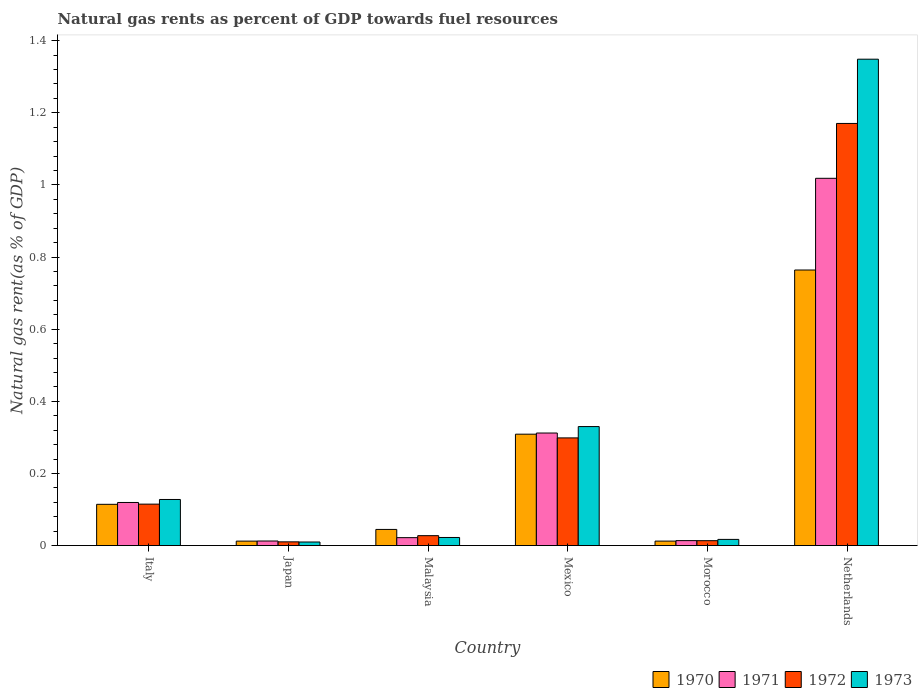Are the number of bars per tick equal to the number of legend labels?
Your answer should be very brief. Yes. What is the label of the 5th group of bars from the left?
Offer a terse response. Morocco. In how many cases, is the number of bars for a given country not equal to the number of legend labels?
Offer a terse response. 0. What is the natural gas rent in 1971 in Japan?
Your response must be concise. 0.01. Across all countries, what is the maximum natural gas rent in 1973?
Ensure brevity in your answer.  1.35. Across all countries, what is the minimum natural gas rent in 1972?
Offer a terse response. 0.01. What is the total natural gas rent in 1970 in the graph?
Ensure brevity in your answer.  1.26. What is the difference between the natural gas rent in 1970 in Japan and that in Mexico?
Offer a very short reply. -0.3. What is the difference between the natural gas rent in 1973 in Malaysia and the natural gas rent in 1970 in Netherlands?
Offer a very short reply. -0.74. What is the average natural gas rent in 1970 per country?
Ensure brevity in your answer.  0.21. What is the difference between the natural gas rent of/in 1970 and natural gas rent of/in 1971 in Netherlands?
Offer a terse response. -0.25. What is the ratio of the natural gas rent in 1972 in Malaysia to that in Netherlands?
Provide a succinct answer. 0.02. What is the difference between the highest and the second highest natural gas rent in 1972?
Your response must be concise. -0.87. What is the difference between the highest and the lowest natural gas rent in 1970?
Ensure brevity in your answer.  0.75. In how many countries, is the natural gas rent in 1973 greater than the average natural gas rent in 1973 taken over all countries?
Your answer should be very brief. 2. Is the sum of the natural gas rent in 1971 in Mexico and Morocco greater than the maximum natural gas rent in 1973 across all countries?
Make the answer very short. No. Is it the case that in every country, the sum of the natural gas rent in 1971 and natural gas rent in 1973 is greater than the sum of natural gas rent in 1972 and natural gas rent in 1970?
Make the answer very short. No. Are all the bars in the graph horizontal?
Give a very brief answer. No. How many countries are there in the graph?
Give a very brief answer. 6. Are the values on the major ticks of Y-axis written in scientific E-notation?
Your answer should be very brief. No. Does the graph contain grids?
Offer a very short reply. No. Where does the legend appear in the graph?
Provide a succinct answer. Bottom right. What is the title of the graph?
Offer a terse response. Natural gas rents as percent of GDP towards fuel resources. Does "1984" appear as one of the legend labels in the graph?
Offer a very short reply. No. What is the label or title of the X-axis?
Provide a short and direct response. Country. What is the label or title of the Y-axis?
Keep it short and to the point. Natural gas rent(as % of GDP). What is the Natural gas rent(as % of GDP) in 1970 in Italy?
Offer a very short reply. 0.11. What is the Natural gas rent(as % of GDP) in 1971 in Italy?
Keep it short and to the point. 0.12. What is the Natural gas rent(as % of GDP) of 1972 in Italy?
Ensure brevity in your answer.  0.11. What is the Natural gas rent(as % of GDP) in 1973 in Italy?
Offer a very short reply. 0.13. What is the Natural gas rent(as % of GDP) of 1970 in Japan?
Offer a terse response. 0.01. What is the Natural gas rent(as % of GDP) in 1971 in Japan?
Give a very brief answer. 0.01. What is the Natural gas rent(as % of GDP) in 1972 in Japan?
Make the answer very short. 0.01. What is the Natural gas rent(as % of GDP) in 1973 in Japan?
Ensure brevity in your answer.  0.01. What is the Natural gas rent(as % of GDP) in 1970 in Malaysia?
Your response must be concise. 0.04. What is the Natural gas rent(as % of GDP) of 1971 in Malaysia?
Provide a succinct answer. 0.02. What is the Natural gas rent(as % of GDP) of 1972 in Malaysia?
Make the answer very short. 0.03. What is the Natural gas rent(as % of GDP) of 1973 in Malaysia?
Provide a short and direct response. 0.02. What is the Natural gas rent(as % of GDP) of 1970 in Mexico?
Your answer should be very brief. 0.31. What is the Natural gas rent(as % of GDP) in 1971 in Mexico?
Provide a succinct answer. 0.31. What is the Natural gas rent(as % of GDP) in 1972 in Mexico?
Offer a terse response. 0.3. What is the Natural gas rent(as % of GDP) in 1973 in Mexico?
Your answer should be compact. 0.33. What is the Natural gas rent(as % of GDP) of 1970 in Morocco?
Ensure brevity in your answer.  0.01. What is the Natural gas rent(as % of GDP) in 1971 in Morocco?
Keep it short and to the point. 0.01. What is the Natural gas rent(as % of GDP) in 1972 in Morocco?
Give a very brief answer. 0.01. What is the Natural gas rent(as % of GDP) in 1973 in Morocco?
Your response must be concise. 0.02. What is the Natural gas rent(as % of GDP) in 1970 in Netherlands?
Keep it short and to the point. 0.76. What is the Natural gas rent(as % of GDP) in 1971 in Netherlands?
Your answer should be very brief. 1.02. What is the Natural gas rent(as % of GDP) of 1972 in Netherlands?
Your response must be concise. 1.17. What is the Natural gas rent(as % of GDP) of 1973 in Netherlands?
Ensure brevity in your answer.  1.35. Across all countries, what is the maximum Natural gas rent(as % of GDP) of 1970?
Your response must be concise. 0.76. Across all countries, what is the maximum Natural gas rent(as % of GDP) of 1971?
Your answer should be very brief. 1.02. Across all countries, what is the maximum Natural gas rent(as % of GDP) in 1972?
Provide a short and direct response. 1.17. Across all countries, what is the maximum Natural gas rent(as % of GDP) in 1973?
Provide a short and direct response. 1.35. Across all countries, what is the minimum Natural gas rent(as % of GDP) in 1970?
Give a very brief answer. 0.01. Across all countries, what is the minimum Natural gas rent(as % of GDP) in 1971?
Give a very brief answer. 0.01. Across all countries, what is the minimum Natural gas rent(as % of GDP) in 1972?
Your response must be concise. 0.01. Across all countries, what is the minimum Natural gas rent(as % of GDP) in 1973?
Offer a terse response. 0.01. What is the total Natural gas rent(as % of GDP) of 1970 in the graph?
Offer a very short reply. 1.26. What is the total Natural gas rent(as % of GDP) of 1971 in the graph?
Give a very brief answer. 1.5. What is the total Natural gas rent(as % of GDP) in 1972 in the graph?
Offer a very short reply. 1.64. What is the total Natural gas rent(as % of GDP) of 1973 in the graph?
Provide a short and direct response. 1.86. What is the difference between the Natural gas rent(as % of GDP) in 1970 in Italy and that in Japan?
Give a very brief answer. 0.1. What is the difference between the Natural gas rent(as % of GDP) in 1971 in Italy and that in Japan?
Keep it short and to the point. 0.11. What is the difference between the Natural gas rent(as % of GDP) of 1972 in Italy and that in Japan?
Provide a short and direct response. 0.1. What is the difference between the Natural gas rent(as % of GDP) of 1973 in Italy and that in Japan?
Offer a very short reply. 0.12. What is the difference between the Natural gas rent(as % of GDP) of 1970 in Italy and that in Malaysia?
Offer a terse response. 0.07. What is the difference between the Natural gas rent(as % of GDP) of 1971 in Italy and that in Malaysia?
Your answer should be very brief. 0.1. What is the difference between the Natural gas rent(as % of GDP) in 1972 in Italy and that in Malaysia?
Make the answer very short. 0.09. What is the difference between the Natural gas rent(as % of GDP) of 1973 in Italy and that in Malaysia?
Offer a terse response. 0.11. What is the difference between the Natural gas rent(as % of GDP) in 1970 in Italy and that in Mexico?
Make the answer very short. -0.19. What is the difference between the Natural gas rent(as % of GDP) of 1971 in Italy and that in Mexico?
Keep it short and to the point. -0.19. What is the difference between the Natural gas rent(as % of GDP) of 1972 in Italy and that in Mexico?
Make the answer very short. -0.18. What is the difference between the Natural gas rent(as % of GDP) of 1973 in Italy and that in Mexico?
Make the answer very short. -0.2. What is the difference between the Natural gas rent(as % of GDP) in 1970 in Italy and that in Morocco?
Provide a succinct answer. 0.1. What is the difference between the Natural gas rent(as % of GDP) in 1971 in Italy and that in Morocco?
Your answer should be very brief. 0.11. What is the difference between the Natural gas rent(as % of GDP) of 1972 in Italy and that in Morocco?
Give a very brief answer. 0.1. What is the difference between the Natural gas rent(as % of GDP) of 1973 in Italy and that in Morocco?
Your answer should be very brief. 0.11. What is the difference between the Natural gas rent(as % of GDP) in 1970 in Italy and that in Netherlands?
Offer a very short reply. -0.65. What is the difference between the Natural gas rent(as % of GDP) of 1971 in Italy and that in Netherlands?
Ensure brevity in your answer.  -0.9. What is the difference between the Natural gas rent(as % of GDP) in 1972 in Italy and that in Netherlands?
Your answer should be very brief. -1.06. What is the difference between the Natural gas rent(as % of GDP) in 1973 in Italy and that in Netherlands?
Provide a short and direct response. -1.22. What is the difference between the Natural gas rent(as % of GDP) in 1970 in Japan and that in Malaysia?
Your answer should be very brief. -0.03. What is the difference between the Natural gas rent(as % of GDP) of 1971 in Japan and that in Malaysia?
Provide a succinct answer. -0.01. What is the difference between the Natural gas rent(as % of GDP) in 1972 in Japan and that in Malaysia?
Provide a short and direct response. -0.02. What is the difference between the Natural gas rent(as % of GDP) in 1973 in Japan and that in Malaysia?
Give a very brief answer. -0.01. What is the difference between the Natural gas rent(as % of GDP) of 1970 in Japan and that in Mexico?
Make the answer very short. -0.3. What is the difference between the Natural gas rent(as % of GDP) in 1971 in Japan and that in Mexico?
Your response must be concise. -0.3. What is the difference between the Natural gas rent(as % of GDP) of 1972 in Japan and that in Mexico?
Provide a succinct answer. -0.29. What is the difference between the Natural gas rent(as % of GDP) of 1973 in Japan and that in Mexico?
Keep it short and to the point. -0.32. What is the difference between the Natural gas rent(as % of GDP) in 1970 in Japan and that in Morocco?
Keep it short and to the point. -0. What is the difference between the Natural gas rent(as % of GDP) of 1971 in Japan and that in Morocco?
Your answer should be very brief. -0. What is the difference between the Natural gas rent(as % of GDP) in 1972 in Japan and that in Morocco?
Provide a succinct answer. -0. What is the difference between the Natural gas rent(as % of GDP) in 1973 in Japan and that in Morocco?
Offer a very short reply. -0.01. What is the difference between the Natural gas rent(as % of GDP) of 1970 in Japan and that in Netherlands?
Your response must be concise. -0.75. What is the difference between the Natural gas rent(as % of GDP) of 1971 in Japan and that in Netherlands?
Make the answer very short. -1.01. What is the difference between the Natural gas rent(as % of GDP) in 1972 in Japan and that in Netherlands?
Offer a very short reply. -1.16. What is the difference between the Natural gas rent(as % of GDP) of 1973 in Japan and that in Netherlands?
Ensure brevity in your answer.  -1.34. What is the difference between the Natural gas rent(as % of GDP) of 1970 in Malaysia and that in Mexico?
Make the answer very short. -0.26. What is the difference between the Natural gas rent(as % of GDP) of 1971 in Malaysia and that in Mexico?
Make the answer very short. -0.29. What is the difference between the Natural gas rent(as % of GDP) in 1972 in Malaysia and that in Mexico?
Offer a terse response. -0.27. What is the difference between the Natural gas rent(as % of GDP) in 1973 in Malaysia and that in Mexico?
Offer a very short reply. -0.31. What is the difference between the Natural gas rent(as % of GDP) in 1970 in Malaysia and that in Morocco?
Your answer should be compact. 0.03. What is the difference between the Natural gas rent(as % of GDP) of 1971 in Malaysia and that in Morocco?
Give a very brief answer. 0.01. What is the difference between the Natural gas rent(as % of GDP) of 1972 in Malaysia and that in Morocco?
Make the answer very short. 0.01. What is the difference between the Natural gas rent(as % of GDP) of 1973 in Malaysia and that in Morocco?
Provide a short and direct response. 0.01. What is the difference between the Natural gas rent(as % of GDP) in 1970 in Malaysia and that in Netherlands?
Provide a short and direct response. -0.72. What is the difference between the Natural gas rent(as % of GDP) of 1971 in Malaysia and that in Netherlands?
Make the answer very short. -1. What is the difference between the Natural gas rent(as % of GDP) in 1972 in Malaysia and that in Netherlands?
Your answer should be very brief. -1.14. What is the difference between the Natural gas rent(as % of GDP) of 1973 in Malaysia and that in Netherlands?
Provide a succinct answer. -1.33. What is the difference between the Natural gas rent(as % of GDP) of 1970 in Mexico and that in Morocco?
Provide a succinct answer. 0.3. What is the difference between the Natural gas rent(as % of GDP) of 1971 in Mexico and that in Morocco?
Keep it short and to the point. 0.3. What is the difference between the Natural gas rent(as % of GDP) of 1972 in Mexico and that in Morocco?
Provide a succinct answer. 0.28. What is the difference between the Natural gas rent(as % of GDP) of 1973 in Mexico and that in Morocco?
Provide a succinct answer. 0.31. What is the difference between the Natural gas rent(as % of GDP) of 1970 in Mexico and that in Netherlands?
Offer a very short reply. -0.46. What is the difference between the Natural gas rent(as % of GDP) in 1971 in Mexico and that in Netherlands?
Make the answer very short. -0.71. What is the difference between the Natural gas rent(as % of GDP) of 1972 in Mexico and that in Netherlands?
Provide a succinct answer. -0.87. What is the difference between the Natural gas rent(as % of GDP) in 1973 in Mexico and that in Netherlands?
Offer a very short reply. -1.02. What is the difference between the Natural gas rent(as % of GDP) in 1970 in Morocco and that in Netherlands?
Give a very brief answer. -0.75. What is the difference between the Natural gas rent(as % of GDP) in 1971 in Morocco and that in Netherlands?
Give a very brief answer. -1. What is the difference between the Natural gas rent(as % of GDP) of 1972 in Morocco and that in Netherlands?
Your answer should be very brief. -1.16. What is the difference between the Natural gas rent(as % of GDP) of 1973 in Morocco and that in Netherlands?
Keep it short and to the point. -1.33. What is the difference between the Natural gas rent(as % of GDP) of 1970 in Italy and the Natural gas rent(as % of GDP) of 1971 in Japan?
Ensure brevity in your answer.  0.1. What is the difference between the Natural gas rent(as % of GDP) in 1970 in Italy and the Natural gas rent(as % of GDP) in 1972 in Japan?
Ensure brevity in your answer.  0.1. What is the difference between the Natural gas rent(as % of GDP) of 1970 in Italy and the Natural gas rent(as % of GDP) of 1973 in Japan?
Keep it short and to the point. 0.1. What is the difference between the Natural gas rent(as % of GDP) in 1971 in Italy and the Natural gas rent(as % of GDP) in 1972 in Japan?
Your answer should be very brief. 0.11. What is the difference between the Natural gas rent(as % of GDP) in 1971 in Italy and the Natural gas rent(as % of GDP) in 1973 in Japan?
Ensure brevity in your answer.  0.11. What is the difference between the Natural gas rent(as % of GDP) in 1972 in Italy and the Natural gas rent(as % of GDP) in 1973 in Japan?
Give a very brief answer. 0.1. What is the difference between the Natural gas rent(as % of GDP) of 1970 in Italy and the Natural gas rent(as % of GDP) of 1971 in Malaysia?
Your response must be concise. 0.09. What is the difference between the Natural gas rent(as % of GDP) in 1970 in Italy and the Natural gas rent(as % of GDP) in 1972 in Malaysia?
Your answer should be compact. 0.09. What is the difference between the Natural gas rent(as % of GDP) of 1970 in Italy and the Natural gas rent(as % of GDP) of 1973 in Malaysia?
Offer a very short reply. 0.09. What is the difference between the Natural gas rent(as % of GDP) in 1971 in Italy and the Natural gas rent(as % of GDP) in 1972 in Malaysia?
Your answer should be very brief. 0.09. What is the difference between the Natural gas rent(as % of GDP) of 1971 in Italy and the Natural gas rent(as % of GDP) of 1973 in Malaysia?
Provide a short and direct response. 0.1. What is the difference between the Natural gas rent(as % of GDP) in 1972 in Italy and the Natural gas rent(as % of GDP) in 1973 in Malaysia?
Ensure brevity in your answer.  0.09. What is the difference between the Natural gas rent(as % of GDP) in 1970 in Italy and the Natural gas rent(as % of GDP) in 1971 in Mexico?
Keep it short and to the point. -0.2. What is the difference between the Natural gas rent(as % of GDP) in 1970 in Italy and the Natural gas rent(as % of GDP) in 1972 in Mexico?
Keep it short and to the point. -0.18. What is the difference between the Natural gas rent(as % of GDP) of 1970 in Italy and the Natural gas rent(as % of GDP) of 1973 in Mexico?
Give a very brief answer. -0.22. What is the difference between the Natural gas rent(as % of GDP) of 1971 in Italy and the Natural gas rent(as % of GDP) of 1972 in Mexico?
Ensure brevity in your answer.  -0.18. What is the difference between the Natural gas rent(as % of GDP) in 1971 in Italy and the Natural gas rent(as % of GDP) in 1973 in Mexico?
Make the answer very short. -0.21. What is the difference between the Natural gas rent(as % of GDP) of 1972 in Italy and the Natural gas rent(as % of GDP) of 1973 in Mexico?
Offer a very short reply. -0.22. What is the difference between the Natural gas rent(as % of GDP) of 1970 in Italy and the Natural gas rent(as % of GDP) of 1971 in Morocco?
Your answer should be very brief. 0.1. What is the difference between the Natural gas rent(as % of GDP) of 1970 in Italy and the Natural gas rent(as % of GDP) of 1972 in Morocco?
Offer a very short reply. 0.1. What is the difference between the Natural gas rent(as % of GDP) of 1970 in Italy and the Natural gas rent(as % of GDP) of 1973 in Morocco?
Offer a very short reply. 0.1. What is the difference between the Natural gas rent(as % of GDP) of 1971 in Italy and the Natural gas rent(as % of GDP) of 1972 in Morocco?
Provide a short and direct response. 0.11. What is the difference between the Natural gas rent(as % of GDP) of 1971 in Italy and the Natural gas rent(as % of GDP) of 1973 in Morocco?
Offer a terse response. 0.1. What is the difference between the Natural gas rent(as % of GDP) of 1972 in Italy and the Natural gas rent(as % of GDP) of 1973 in Morocco?
Offer a very short reply. 0.1. What is the difference between the Natural gas rent(as % of GDP) in 1970 in Italy and the Natural gas rent(as % of GDP) in 1971 in Netherlands?
Give a very brief answer. -0.9. What is the difference between the Natural gas rent(as % of GDP) in 1970 in Italy and the Natural gas rent(as % of GDP) in 1972 in Netherlands?
Your answer should be very brief. -1.06. What is the difference between the Natural gas rent(as % of GDP) in 1970 in Italy and the Natural gas rent(as % of GDP) in 1973 in Netherlands?
Provide a succinct answer. -1.23. What is the difference between the Natural gas rent(as % of GDP) of 1971 in Italy and the Natural gas rent(as % of GDP) of 1972 in Netherlands?
Keep it short and to the point. -1.05. What is the difference between the Natural gas rent(as % of GDP) in 1971 in Italy and the Natural gas rent(as % of GDP) in 1973 in Netherlands?
Offer a very short reply. -1.23. What is the difference between the Natural gas rent(as % of GDP) in 1972 in Italy and the Natural gas rent(as % of GDP) in 1973 in Netherlands?
Keep it short and to the point. -1.23. What is the difference between the Natural gas rent(as % of GDP) of 1970 in Japan and the Natural gas rent(as % of GDP) of 1971 in Malaysia?
Your response must be concise. -0.01. What is the difference between the Natural gas rent(as % of GDP) of 1970 in Japan and the Natural gas rent(as % of GDP) of 1972 in Malaysia?
Your answer should be compact. -0.02. What is the difference between the Natural gas rent(as % of GDP) of 1970 in Japan and the Natural gas rent(as % of GDP) of 1973 in Malaysia?
Your response must be concise. -0.01. What is the difference between the Natural gas rent(as % of GDP) in 1971 in Japan and the Natural gas rent(as % of GDP) in 1972 in Malaysia?
Your answer should be very brief. -0.01. What is the difference between the Natural gas rent(as % of GDP) of 1971 in Japan and the Natural gas rent(as % of GDP) of 1973 in Malaysia?
Make the answer very short. -0.01. What is the difference between the Natural gas rent(as % of GDP) of 1972 in Japan and the Natural gas rent(as % of GDP) of 1973 in Malaysia?
Your answer should be very brief. -0.01. What is the difference between the Natural gas rent(as % of GDP) of 1970 in Japan and the Natural gas rent(as % of GDP) of 1971 in Mexico?
Give a very brief answer. -0.3. What is the difference between the Natural gas rent(as % of GDP) in 1970 in Japan and the Natural gas rent(as % of GDP) in 1972 in Mexico?
Keep it short and to the point. -0.29. What is the difference between the Natural gas rent(as % of GDP) in 1970 in Japan and the Natural gas rent(as % of GDP) in 1973 in Mexico?
Keep it short and to the point. -0.32. What is the difference between the Natural gas rent(as % of GDP) of 1971 in Japan and the Natural gas rent(as % of GDP) of 1972 in Mexico?
Keep it short and to the point. -0.29. What is the difference between the Natural gas rent(as % of GDP) in 1971 in Japan and the Natural gas rent(as % of GDP) in 1973 in Mexico?
Your answer should be compact. -0.32. What is the difference between the Natural gas rent(as % of GDP) in 1972 in Japan and the Natural gas rent(as % of GDP) in 1973 in Mexico?
Offer a terse response. -0.32. What is the difference between the Natural gas rent(as % of GDP) in 1970 in Japan and the Natural gas rent(as % of GDP) in 1971 in Morocco?
Provide a short and direct response. -0. What is the difference between the Natural gas rent(as % of GDP) in 1970 in Japan and the Natural gas rent(as % of GDP) in 1972 in Morocco?
Offer a terse response. -0. What is the difference between the Natural gas rent(as % of GDP) in 1970 in Japan and the Natural gas rent(as % of GDP) in 1973 in Morocco?
Offer a terse response. -0. What is the difference between the Natural gas rent(as % of GDP) in 1971 in Japan and the Natural gas rent(as % of GDP) in 1972 in Morocco?
Your response must be concise. -0. What is the difference between the Natural gas rent(as % of GDP) in 1971 in Japan and the Natural gas rent(as % of GDP) in 1973 in Morocco?
Offer a very short reply. -0. What is the difference between the Natural gas rent(as % of GDP) in 1972 in Japan and the Natural gas rent(as % of GDP) in 1973 in Morocco?
Your response must be concise. -0.01. What is the difference between the Natural gas rent(as % of GDP) of 1970 in Japan and the Natural gas rent(as % of GDP) of 1971 in Netherlands?
Offer a terse response. -1.01. What is the difference between the Natural gas rent(as % of GDP) in 1970 in Japan and the Natural gas rent(as % of GDP) in 1972 in Netherlands?
Your answer should be compact. -1.16. What is the difference between the Natural gas rent(as % of GDP) in 1970 in Japan and the Natural gas rent(as % of GDP) in 1973 in Netherlands?
Keep it short and to the point. -1.34. What is the difference between the Natural gas rent(as % of GDP) of 1971 in Japan and the Natural gas rent(as % of GDP) of 1972 in Netherlands?
Give a very brief answer. -1.16. What is the difference between the Natural gas rent(as % of GDP) of 1971 in Japan and the Natural gas rent(as % of GDP) of 1973 in Netherlands?
Ensure brevity in your answer.  -1.34. What is the difference between the Natural gas rent(as % of GDP) in 1972 in Japan and the Natural gas rent(as % of GDP) in 1973 in Netherlands?
Offer a terse response. -1.34. What is the difference between the Natural gas rent(as % of GDP) in 1970 in Malaysia and the Natural gas rent(as % of GDP) in 1971 in Mexico?
Make the answer very short. -0.27. What is the difference between the Natural gas rent(as % of GDP) in 1970 in Malaysia and the Natural gas rent(as % of GDP) in 1972 in Mexico?
Give a very brief answer. -0.25. What is the difference between the Natural gas rent(as % of GDP) of 1970 in Malaysia and the Natural gas rent(as % of GDP) of 1973 in Mexico?
Offer a very short reply. -0.29. What is the difference between the Natural gas rent(as % of GDP) of 1971 in Malaysia and the Natural gas rent(as % of GDP) of 1972 in Mexico?
Offer a terse response. -0.28. What is the difference between the Natural gas rent(as % of GDP) in 1971 in Malaysia and the Natural gas rent(as % of GDP) in 1973 in Mexico?
Your answer should be compact. -0.31. What is the difference between the Natural gas rent(as % of GDP) in 1972 in Malaysia and the Natural gas rent(as % of GDP) in 1973 in Mexico?
Your response must be concise. -0.3. What is the difference between the Natural gas rent(as % of GDP) of 1970 in Malaysia and the Natural gas rent(as % of GDP) of 1971 in Morocco?
Provide a short and direct response. 0.03. What is the difference between the Natural gas rent(as % of GDP) in 1970 in Malaysia and the Natural gas rent(as % of GDP) in 1972 in Morocco?
Provide a short and direct response. 0.03. What is the difference between the Natural gas rent(as % of GDP) of 1970 in Malaysia and the Natural gas rent(as % of GDP) of 1973 in Morocco?
Provide a short and direct response. 0.03. What is the difference between the Natural gas rent(as % of GDP) of 1971 in Malaysia and the Natural gas rent(as % of GDP) of 1972 in Morocco?
Ensure brevity in your answer.  0.01. What is the difference between the Natural gas rent(as % of GDP) in 1971 in Malaysia and the Natural gas rent(as % of GDP) in 1973 in Morocco?
Your response must be concise. 0. What is the difference between the Natural gas rent(as % of GDP) in 1972 in Malaysia and the Natural gas rent(as % of GDP) in 1973 in Morocco?
Your answer should be very brief. 0.01. What is the difference between the Natural gas rent(as % of GDP) in 1970 in Malaysia and the Natural gas rent(as % of GDP) in 1971 in Netherlands?
Your answer should be compact. -0.97. What is the difference between the Natural gas rent(as % of GDP) of 1970 in Malaysia and the Natural gas rent(as % of GDP) of 1972 in Netherlands?
Your answer should be very brief. -1.13. What is the difference between the Natural gas rent(as % of GDP) in 1970 in Malaysia and the Natural gas rent(as % of GDP) in 1973 in Netherlands?
Your answer should be very brief. -1.3. What is the difference between the Natural gas rent(as % of GDP) of 1971 in Malaysia and the Natural gas rent(as % of GDP) of 1972 in Netherlands?
Ensure brevity in your answer.  -1.15. What is the difference between the Natural gas rent(as % of GDP) of 1971 in Malaysia and the Natural gas rent(as % of GDP) of 1973 in Netherlands?
Give a very brief answer. -1.33. What is the difference between the Natural gas rent(as % of GDP) of 1972 in Malaysia and the Natural gas rent(as % of GDP) of 1973 in Netherlands?
Give a very brief answer. -1.32. What is the difference between the Natural gas rent(as % of GDP) in 1970 in Mexico and the Natural gas rent(as % of GDP) in 1971 in Morocco?
Your answer should be very brief. 0.3. What is the difference between the Natural gas rent(as % of GDP) in 1970 in Mexico and the Natural gas rent(as % of GDP) in 1972 in Morocco?
Give a very brief answer. 0.3. What is the difference between the Natural gas rent(as % of GDP) in 1970 in Mexico and the Natural gas rent(as % of GDP) in 1973 in Morocco?
Provide a short and direct response. 0.29. What is the difference between the Natural gas rent(as % of GDP) in 1971 in Mexico and the Natural gas rent(as % of GDP) in 1972 in Morocco?
Make the answer very short. 0.3. What is the difference between the Natural gas rent(as % of GDP) of 1971 in Mexico and the Natural gas rent(as % of GDP) of 1973 in Morocco?
Your answer should be very brief. 0.29. What is the difference between the Natural gas rent(as % of GDP) in 1972 in Mexico and the Natural gas rent(as % of GDP) in 1973 in Morocco?
Make the answer very short. 0.28. What is the difference between the Natural gas rent(as % of GDP) of 1970 in Mexico and the Natural gas rent(as % of GDP) of 1971 in Netherlands?
Offer a terse response. -0.71. What is the difference between the Natural gas rent(as % of GDP) in 1970 in Mexico and the Natural gas rent(as % of GDP) in 1972 in Netherlands?
Offer a terse response. -0.86. What is the difference between the Natural gas rent(as % of GDP) in 1970 in Mexico and the Natural gas rent(as % of GDP) in 1973 in Netherlands?
Your answer should be compact. -1.04. What is the difference between the Natural gas rent(as % of GDP) in 1971 in Mexico and the Natural gas rent(as % of GDP) in 1972 in Netherlands?
Provide a succinct answer. -0.86. What is the difference between the Natural gas rent(as % of GDP) in 1971 in Mexico and the Natural gas rent(as % of GDP) in 1973 in Netherlands?
Keep it short and to the point. -1.04. What is the difference between the Natural gas rent(as % of GDP) of 1972 in Mexico and the Natural gas rent(as % of GDP) of 1973 in Netherlands?
Offer a very short reply. -1.05. What is the difference between the Natural gas rent(as % of GDP) in 1970 in Morocco and the Natural gas rent(as % of GDP) in 1971 in Netherlands?
Make the answer very short. -1.01. What is the difference between the Natural gas rent(as % of GDP) in 1970 in Morocco and the Natural gas rent(as % of GDP) in 1972 in Netherlands?
Provide a short and direct response. -1.16. What is the difference between the Natural gas rent(as % of GDP) of 1970 in Morocco and the Natural gas rent(as % of GDP) of 1973 in Netherlands?
Give a very brief answer. -1.34. What is the difference between the Natural gas rent(as % of GDP) in 1971 in Morocco and the Natural gas rent(as % of GDP) in 1972 in Netherlands?
Your response must be concise. -1.16. What is the difference between the Natural gas rent(as % of GDP) in 1971 in Morocco and the Natural gas rent(as % of GDP) in 1973 in Netherlands?
Your answer should be compact. -1.33. What is the difference between the Natural gas rent(as % of GDP) in 1972 in Morocco and the Natural gas rent(as % of GDP) in 1973 in Netherlands?
Your response must be concise. -1.34. What is the average Natural gas rent(as % of GDP) of 1970 per country?
Offer a very short reply. 0.21. What is the average Natural gas rent(as % of GDP) in 1971 per country?
Your answer should be compact. 0.25. What is the average Natural gas rent(as % of GDP) of 1972 per country?
Your answer should be very brief. 0.27. What is the average Natural gas rent(as % of GDP) in 1973 per country?
Give a very brief answer. 0.31. What is the difference between the Natural gas rent(as % of GDP) in 1970 and Natural gas rent(as % of GDP) in 1971 in Italy?
Offer a terse response. -0.01. What is the difference between the Natural gas rent(as % of GDP) of 1970 and Natural gas rent(as % of GDP) of 1972 in Italy?
Give a very brief answer. -0. What is the difference between the Natural gas rent(as % of GDP) of 1970 and Natural gas rent(as % of GDP) of 1973 in Italy?
Provide a succinct answer. -0.01. What is the difference between the Natural gas rent(as % of GDP) of 1971 and Natural gas rent(as % of GDP) of 1972 in Italy?
Your response must be concise. 0. What is the difference between the Natural gas rent(as % of GDP) in 1971 and Natural gas rent(as % of GDP) in 1973 in Italy?
Give a very brief answer. -0.01. What is the difference between the Natural gas rent(as % of GDP) of 1972 and Natural gas rent(as % of GDP) of 1973 in Italy?
Ensure brevity in your answer.  -0.01. What is the difference between the Natural gas rent(as % of GDP) in 1970 and Natural gas rent(as % of GDP) in 1971 in Japan?
Ensure brevity in your answer.  -0. What is the difference between the Natural gas rent(as % of GDP) of 1970 and Natural gas rent(as % of GDP) of 1972 in Japan?
Offer a terse response. 0. What is the difference between the Natural gas rent(as % of GDP) of 1970 and Natural gas rent(as % of GDP) of 1973 in Japan?
Give a very brief answer. 0. What is the difference between the Natural gas rent(as % of GDP) in 1971 and Natural gas rent(as % of GDP) in 1972 in Japan?
Ensure brevity in your answer.  0. What is the difference between the Natural gas rent(as % of GDP) of 1971 and Natural gas rent(as % of GDP) of 1973 in Japan?
Keep it short and to the point. 0. What is the difference between the Natural gas rent(as % of GDP) in 1972 and Natural gas rent(as % of GDP) in 1973 in Japan?
Your answer should be very brief. 0. What is the difference between the Natural gas rent(as % of GDP) in 1970 and Natural gas rent(as % of GDP) in 1971 in Malaysia?
Your answer should be very brief. 0.02. What is the difference between the Natural gas rent(as % of GDP) in 1970 and Natural gas rent(as % of GDP) in 1972 in Malaysia?
Your answer should be compact. 0.02. What is the difference between the Natural gas rent(as % of GDP) in 1970 and Natural gas rent(as % of GDP) in 1973 in Malaysia?
Make the answer very short. 0.02. What is the difference between the Natural gas rent(as % of GDP) in 1971 and Natural gas rent(as % of GDP) in 1972 in Malaysia?
Your response must be concise. -0.01. What is the difference between the Natural gas rent(as % of GDP) in 1971 and Natural gas rent(as % of GDP) in 1973 in Malaysia?
Your answer should be compact. -0. What is the difference between the Natural gas rent(as % of GDP) of 1972 and Natural gas rent(as % of GDP) of 1973 in Malaysia?
Offer a terse response. 0.01. What is the difference between the Natural gas rent(as % of GDP) of 1970 and Natural gas rent(as % of GDP) of 1971 in Mexico?
Provide a succinct answer. -0. What is the difference between the Natural gas rent(as % of GDP) of 1970 and Natural gas rent(as % of GDP) of 1972 in Mexico?
Ensure brevity in your answer.  0.01. What is the difference between the Natural gas rent(as % of GDP) of 1970 and Natural gas rent(as % of GDP) of 1973 in Mexico?
Your answer should be very brief. -0.02. What is the difference between the Natural gas rent(as % of GDP) in 1971 and Natural gas rent(as % of GDP) in 1972 in Mexico?
Give a very brief answer. 0.01. What is the difference between the Natural gas rent(as % of GDP) in 1971 and Natural gas rent(as % of GDP) in 1973 in Mexico?
Your answer should be very brief. -0.02. What is the difference between the Natural gas rent(as % of GDP) in 1972 and Natural gas rent(as % of GDP) in 1973 in Mexico?
Provide a succinct answer. -0.03. What is the difference between the Natural gas rent(as % of GDP) in 1970 and Natural gas rent(as % of GDP) in 1971 in Morocco?
Make the answer very short. -0. What is the difference between the Natural gas rent(as % of GDP) in 1970 and Natural gas rent(as % of GDP) in 1972 in Morocco?
Your answer should be compact. -0. What is the difference between the Natural gas rent(as % of GDP) in 1970 and Natural gas rent(as % of GDP) in 1973 in Morocco?
Give a very brief answer. -0. What is the difference between the Natural gas rent(as % of GDP) of 1971 and Natural gas rent(as % of GDP) of 1972 in Morocco?
Keep it short and to the point. 0. What is the difference between the Natural gas rent(as % of GDP) in 1971 and Natural gas rent(as % of GDP) in 1973 in Morocco?
Your response must be concise. -0. What is the difference between the Natural gas rent(as % of GDP) in 1972 and Natural gas rent(as % of GDP) in 1973 in Morocco?
Ensure brevity in your answer.  -0. What is the difference between the Natural gas rent(as % of GDP) of 1970 and Natural gas rent(as % of GDP) of 1971 in Netherlands?
Give a very brief answer. -0.25. What is the difference between the Natural gas rent(as % of GDP) of 1970 and Natural gas rent(as % of GDP) of 1972 in Netherlands?
Ensure brevity in your answer.  -0.41. What is the difference between the Natural gas rent(as % of GDP) of 1970 and Natural gas rent(as % of GDP) of 1973 in Netherlands?
Your answer should be compact. -0.58. What is the difference between the Natural gas rent(as % of GDP) of 1971 and Natural gas rent(as % of GDP) of 1972 in Netherlands?
Make the answer very short. -0.15. What is the difference between the Natural gas rent(as % of GDP) of 1971 and Natural gas rent(as % of GDP) of 1973 in Netherlands?
Keep it short and to the point. -0.33. What is the difference between the Natural gas rent(as % of GDP) of 1972 and Natural gas rent(as % of GDP) of 1973 in Netherlands?
Keep it short and to the point. -0.18. What is the ratio of the Natural gas rent(as % of GDP) of 1970 in Italy to that in Japan?
Give a very brief answer. 9.27. What is the ratio of the Natural gas rent(as % of GDP) of 1971 in Italy to that in Japan?
Make the answer very short. 9.46. What is the ratio of the Natural gas rent(as % of GDP) of 1972 in Italy to that in Japan?
Make the answer very short. 11.16. What is the ratio of the Natural gas rent(as % of GDP) of 1973 in Italy to that in Japan?
Provide a succinct answer. 12.96. What is the ratio of the Natural gas rent(as % of GDP) of 1970 in Italy to that in Malaysia?
Your answer should be very brief. 2.56. What is the ratio of the Natural gas rent(as % of GDP) in 1971 in Italy to that in Malaysia?
Provide a short and direct response. 5.45. What is the ratio of the Natural gas rent(as % of GDP) of 1972 in Italy to that in Malaysia?
Ensure brevity in your answer.  4.19. What is the ratio of the Natural gas rent(as % of GDP) of 1973 in Italy to that in Malaysia?
Your answer should be compact. 5.7. What is the ratio of the Natural gas rent(as % of GDP) of 1970 in Italy to that in Mexico?
Your answer should be compact. 0.37. What is the ratio of the Natural gas rent(as % of GDP) of 1971 in Italy to that in Mexico?
Provide a succinct answer. 0.38. What is the ratio of the Natural gas rent(as % of GDP) of 1972 in Italy to that in Mexico?
Offer a terse response. 0.38. What is the ratio of the Natural gas rent(as % of GDP) in 1973 in Italy to that in Mexico?
Ensure brevity in your answer.  0.39. What is the ratio of the Natural gas rent(as % of GDP) of 1970 in Italy to that in Morocco?
Your response must be concise. 9.25. What is the ratio of the Natural gas rent(as % of GDP) in 1971 in Italy to that in Morocco?
Provide a short and direct response. 8.7. What is the ratio of the Natural gas rent(as % of GDP) of 1972 in Italy to that in Morocco?
Your answer should be very brief. 8.48. What is the ratio of the Natural gas rent(as % of GDP) in 1973 in Italy to that in Morocco?
Your response must be concise. 7.47. What is the ratio of the Natural gas rent(as % of GDP) in 1970 in Italy to that in Netherlands?
Offer a terse response. 0.15. What is the ratio of the Natural gas rent(as % of GDP) in 1971 in Italy to that in Netherlands?
Your answer should be very brief. 0.12. What is the ratio of the Natural gas rent(as % of GDP) in 1972 in Italy to that in Netherlands?
Make the answer very short. 0.1. What is the ratio of the Natural gas rent(as % of GDP) of 1973 in Italy to that in Netherlands?
Offer a terse response. 0.09. What is the ratio of the Natural gas rent(as % of GDP) in 1970 in Japan to that in Malaysia?
Provide a succinct answer. 0.28. What is the ratio of the Natural gas rent(as % of GDP) of 1971 in Japan to that in Malaysia?
Make the answer very short. 0.58. What is the ratio of the Natural gas rent(as % of GDP) of 1972 in Japan to that in Malaysia?
Provide a short and direct response. 0.38. What is the ratio of the Natural gas rent(as % of GDP) of 1973 in Japan to that in Malaysia?
Ensure brevity in your answer.  0.44. What is the ratio of the Natural gas rent(as % of GDP) of 1970 in Japan to that in Mexico?
Give a very brief answer. 0.04. What is the ratio of the Natural gas rent(as % of GDP) in 1971 in Japan to that in Mexico?
Keep it short and to the point. 0.04. What is the ratio of the Natural gas rent(as % of GDP) in 1972 in Japan to that in Mexico?
Make the answer very short. 0.03. What is the ratio of the Natural gas rent(as % of GDP) in 1973 in Japan to that in Mexico?
Keep it short and to the point. 0.03. What is the ratio of the Natural gas rent(as % of GDP) of 1970 in Japan to that in Morocco?
Your response must be concise. 1. What is the ratio of the Natural gas rent(as % of GDP) of 1972 in Japan to that in Morocco?
Provide a short and direct response. 0.76. What is the ratio of the Natural gas rent(as % of GDP) of 1973 in Japan to that in Morocco?
Your answer should be compact. 0.58. What is the ratio of the Natural gas rent(as % of GDP) of 1970 in Japan to that in Netherlands?
Provide a succinct answer. 0.02. What is the ratio of the Natural gas rent(as % of GDP) of 1971 in Japan to that in Netherlands?
Ensure brevity in your answer.  0.01. What is the ratio of the Natural gas rent(as % of GDP) in 1972 in Japan to that in Netherlands?
Offer a very short reply. 0.01. What is the ratio of the Natural gas rent(as % of GDP) of 1973 in Japan to that in Netherlands?
Your answer should be very brief. 0.01. What is the ratio of the Natural gas rent(as % of GDP) of 1970 in Malaysia to that in Mexico?
Offer a very short reply. 0.14. What is the ratio of the Natural gas rent(as % of GDP) of 1971 in Malaysia to that in Mexico?
Your answer should be compact. 0.07. What is the ratio of the Natural gas rent(as % of GDP) of 1972 in Malaysia to that in Mexico?
Keep it short and to the point. 0.09. What is the ratio of the Natural gas rent(as % of GDP) of 1973 in Malaysia to that in Mexico?
Offer a terse response. 0.07. What is the ratio of the Natural gas rent(as % of GDP) of 1970 in Malaysia to that in Morocco?
Your answer should be very brief. 3.62. What is the ratio of the Natural gas rent(as % of GDP) in 1971 in Malaysia to that in Morocco?
Provide a short and direct response. 1.6. What is the ratio of the Natural gas rent(as % of GDP) of 1972 in Malaysia to that in Morocco?
Give a very brief answer. 2.03. What is the ratio of the Natural gas rent(as % of GDP) in 1973 in Malaysia to that in Morocco?
Provide a succinct answer. 1.31. What is the ratio of the Natural gas rent(as % of GDP) in 1970 in Malaysia to that in Netherlands?
Your answer should be compact. 0.06. What is the ratio of the Natural gas rent(as % of GDP) in 1971 in Malaysia to that in Netherlands?
Provide a short and direct response. 0.02. What is the ratio of the Natural gas rent(as % of GDP) of 1972 in Malaysia to that in Netherlands?
Your response must be concise. 0.02. What is the ratio of the Natural gas rent(as % of GDP) of 1973 in Malaysia to that in Netherlands?
Give a very brief answer. 0.02. What is the ratio of the Natural gas rent(as % of GDP) of 1970 in Mexico to that in Morocco?
Make the answer very short. 25. What is the ratio of the Natural gas rent(as % of GDP) in 1971 in Mexico to that in Morocco?
Your response must be concise. 22.74. What is the ratio of the Natural gas rent(as % of GDP) of 1972 in Mexico to that in Morocco?
Your answer should be compact. 22.04. What is the ratio of the Natural gas rent(as % of GDP) in 1973 in Mexico to that in Morocco?
Offer a very short reply. 19.3. What is the ratio of the Natural gas rent(as % of GDP) in 1970 in Mexico to that in Netherlands?
Offer a terse response. 0.4. What is the ratio of the Natural gas rent(as % of GDP) in 1971 in Mexico to that in Netherlands?
Offer a terse response. 0.31. What is the ratio of the Natural gas rent(as % of GDP) of 1972 in Mexico to that in Netherlands?
Provide a short and direct response. 0.26. What is the ratio of the Natural gas rent(as % of GDP) in 1973 in Mexico to that in Netherlands?
Provide a succinct answer. 0.24. What is the ratio of the Natural gas rent(as % of GDP) in 1970 in Morocco to that in Netherlands?
Offer a very short reply. 0.02. What is the ratio of the Natural gas rent(as % of GDP) of 1971 in Morocco to that in Netherlands?
Provide a succinct answer. 0.01. What is the ratio of the Natural gas rent(as % of GDP) of 1972 in Morocco to that in Netherlands?
Your answer should be very brief. 0.01. What is the ratio of the Natural gas rent(as % of GDP) in 1973 in Morocco to that in Netherlands?
Your response must be concise. 0.01. What is the difference between the highest and the second highest Natural gas rent(as % of GDP) of 1970?
Make the answer very short. 0.46. What is the difference between the highest and the second highest Natural gas rent(as % of GDP) in 1971?
Your answer should be very brief. 0.71. What is the difference between the highest and the second highest Natural gas rent(as % of GDP) of 1972?
Offer a terse response. 0.87. What is the difference between the highest and the second highest Natural gas rent(as % of GDP) of 1973?
Give a very brief answer. 1.02. What is the difference between the highest and the lowest Natural gas rent(as % of GDP) in 1970?
Your response must be concise. 0.75. What is the difference between the highest and the lowest Natural gas rent(as % of GDP) in 1971?
Your answer should be very brief. 1.01. What is the difference between the highest and the lowest Natural gas rent(as % of GDP) of 1972?
Make the answer very short. 1.16. What is the difference between the highest and the lowest Natural gas rent(as % of GDP) in 1973?
Make the answer very short. 1.34. 